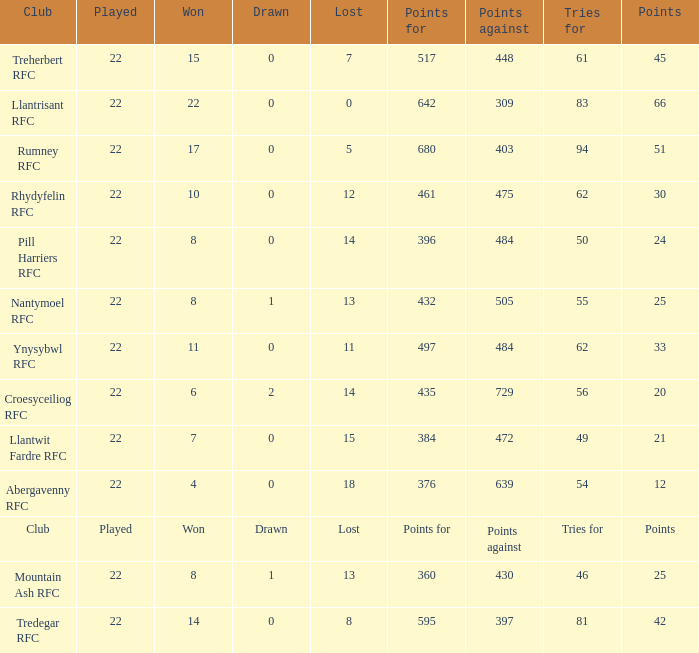How many tries for were scored by the team that had exactly 396 points for? 50.0. 